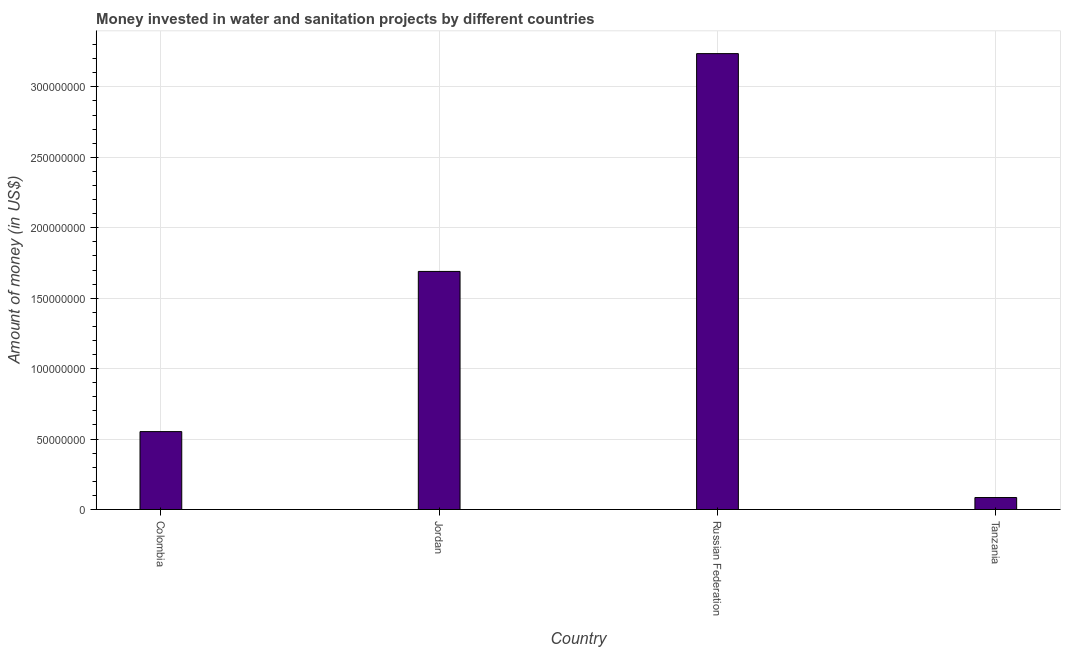Does the graph contain any zero values?
Ensure brevity in your answer.  No. What is the title of the graph?
Offer a very short reply. Money invested in water and sanitation projects by different countries. What is the label or title of the Y-axis?
Your answer should be very brief. Amount of money (in US$). What is the investment in Tanzania?
Provide a short and direct response. 8.50e+06. Across all countries, what is the maximum investment?
Give a very brief answer. 3.24e+08. Across all countries, what is the minimum investment?
Give a very brief answer. 8.50e+06. In which country was the investment maximum?
Offer a very short reply. Russian Federation. In which country was the investment minimum?
Your answer should be very brief. Tanzania. What is the sum of the investment?
Keep it short and to the point. 5.56e+08. What is the difference between the investment in Russian Federation and Tanzania?
Provide a short and direct response. 3.15e+08. What is the average investment per country?
Make the answer very short. 1.39e+08. What is the median investment?
Offer a terse response. 1.12e+08. What is the ratio of the investment in Jordan to that in Russian Federation?
Your answer should be very brief. 0.52. Is the investment in Russian Federation less than that in Tanzania?
Provide a short and direct response. No. What is the difference between the highest and the second highest investment?
Your answer should be compact. 1.55e+08. What is the difference between the highest and the lowest investment?
Offer a very short reply. 3.15e+08. In how many countries, is the investment greater than the average investment taken over all countries?
Offer a very short reply. 2. How many bars are there?
Ensure brevity in your answer.  4. Are all the bars in the graph horizontal?
Your response must be concise. No. What is the difference between two consecutive major ticks on the Y-axis?
Give a very brief answer. 5.00e+07. What is the Amount of money (in US$) in Colombia?
Your answer should be very brief. 5.53e+07. What is the Amount of money (in US$) in Jordan?
Your answer should be compact. 1.69e+08. What is the Amount of money (in US$) of Russian Federation?
Provide a succinct answer. 3.24e+08. What is the Amount of money (in US$) in Tanzania?
Offer a very short reply. 8.50e+06. What is the difference between the Amount of money (in US$) in Colombia and Jordan?
Provide a short and direct response. -1.14e+08. What is the difference between the Amount of money (in US$) in Colombia and Russian Federation?
Your answer should be compact. -2.68e+08. What is the difference between the Amount of money (in US$) in Colombia and Tanzania?
Keep it short and to the point. 4.68e+07. What is the difference between the Amount of money (in US$) in Jordan and Russian Federation?
Give a very brief answer. -1.55e+08. What is the difference between the Amount of money (in US$) in Jordan and Tanzania?
Offer a terse response. 1.60e+08. What is the difference between the Amount of money (in US$) in Russian Federation and Tanzania?
Provide a short and direct response. 3.15e+08. What is the ratio of the Amount of money (in US$) in Colombia to that in Jordan?
Your response must be concise. 0.33. What is the ratio of the Amount of money (in US$) in Colombia to that in Russian Federation?
Keep it short and to the point. 0.17. What is the ratio of the Amount of money (in US$) in Colombia to that in Tanzania?
Your answer should be compact. 6.51. What is the ratio of the Amount of money (in US$) in Jordan to that in Russian Federation?
Your answer should be compact. 0.52. What is the ratio of the Amount of money (in US$) in Jordan to that in Tanzania?
Your answer should be compact. 19.88. What is the ratio of the Amount of money (in US$) in Russian Federation to that in Tanzania?
Ensure brevity in your answer.  38.07. 